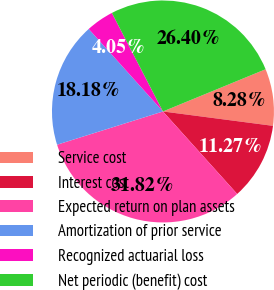Convert chart to OTSL. <chart><loc_0><loc_0><loc_500><loc_500><pie_chart><fcel>Service cost<fcel>Interest cost<fcel>Expected return on plan assets<fcel>Amortization of prior service<fcel>Recognized actuarial loss<fcel>Net periodic (benefit) cost<nl><fcel>8.28%<fcel>11.27%<fcel>31.82%<fcel>18.18%<fcel>4.05%<fcel>26.4%<nl></chart> 